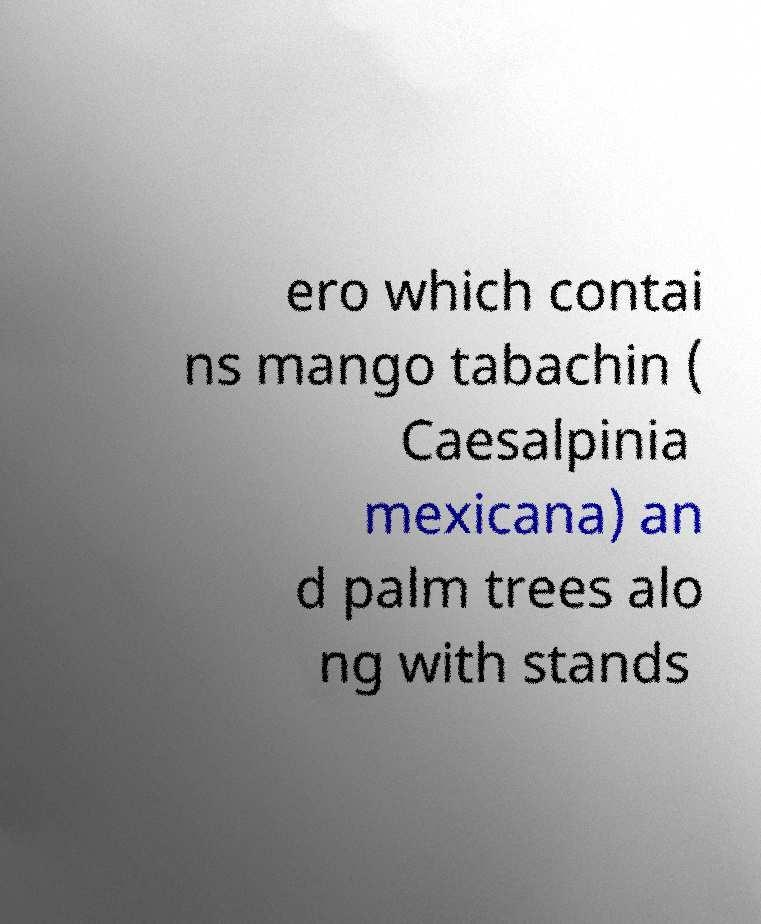Please identify and transcribe the text found in this image. ero which contai ns mango tabachin ( Caesalpinia mexicana) an d palm trees alo ng with stands 